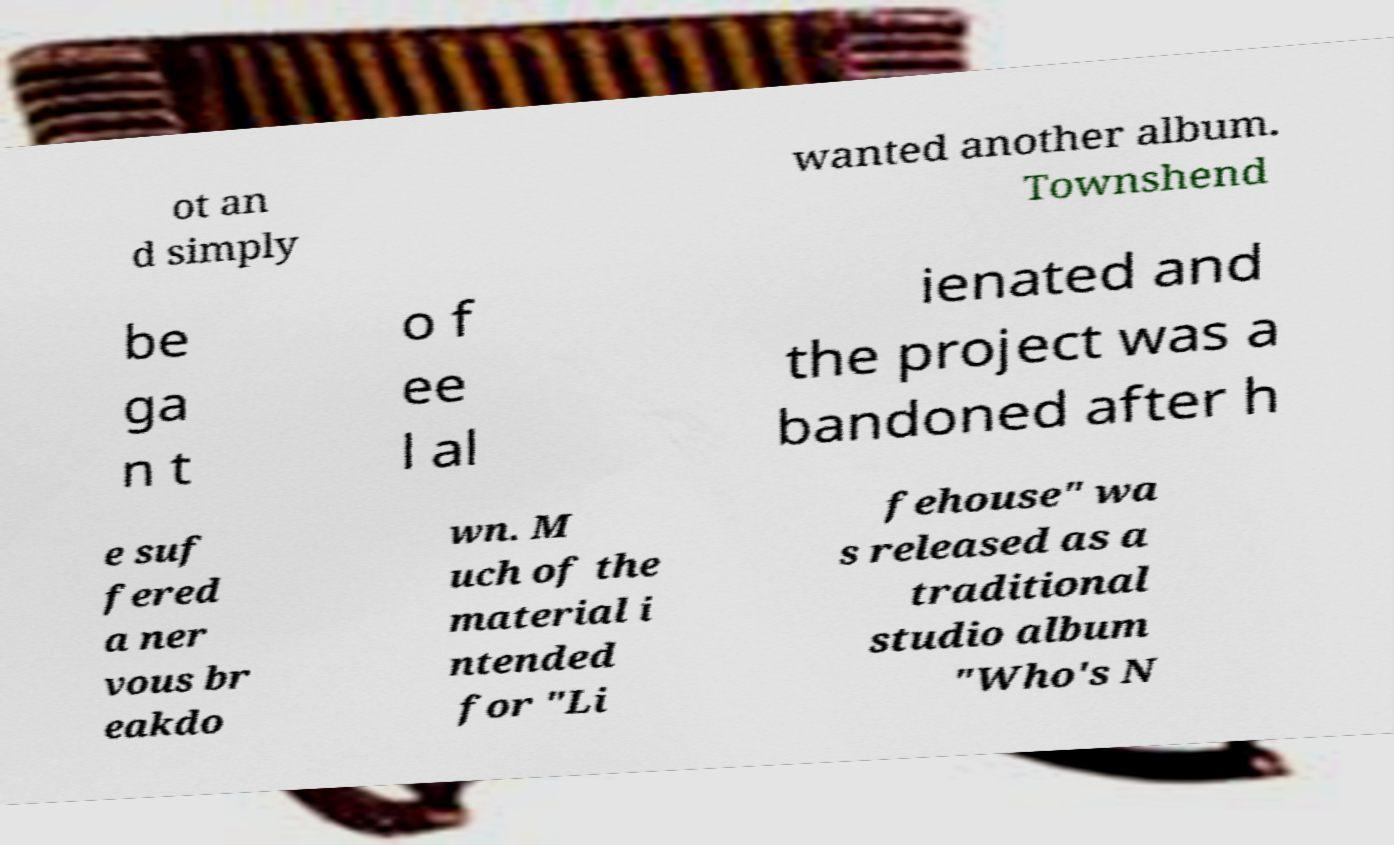There's text embedded in this image that I need extracted. Can you transcribe it verbatim? ot an d simply wanted another album. Townshend be ga n t o f ee l al ienated and the project was a bandoned after h e suf fered a ner vous br eakdo wn. M uch of the material i ntended for "Li fehouse" wa s released as a traditional studio album "Who's N 